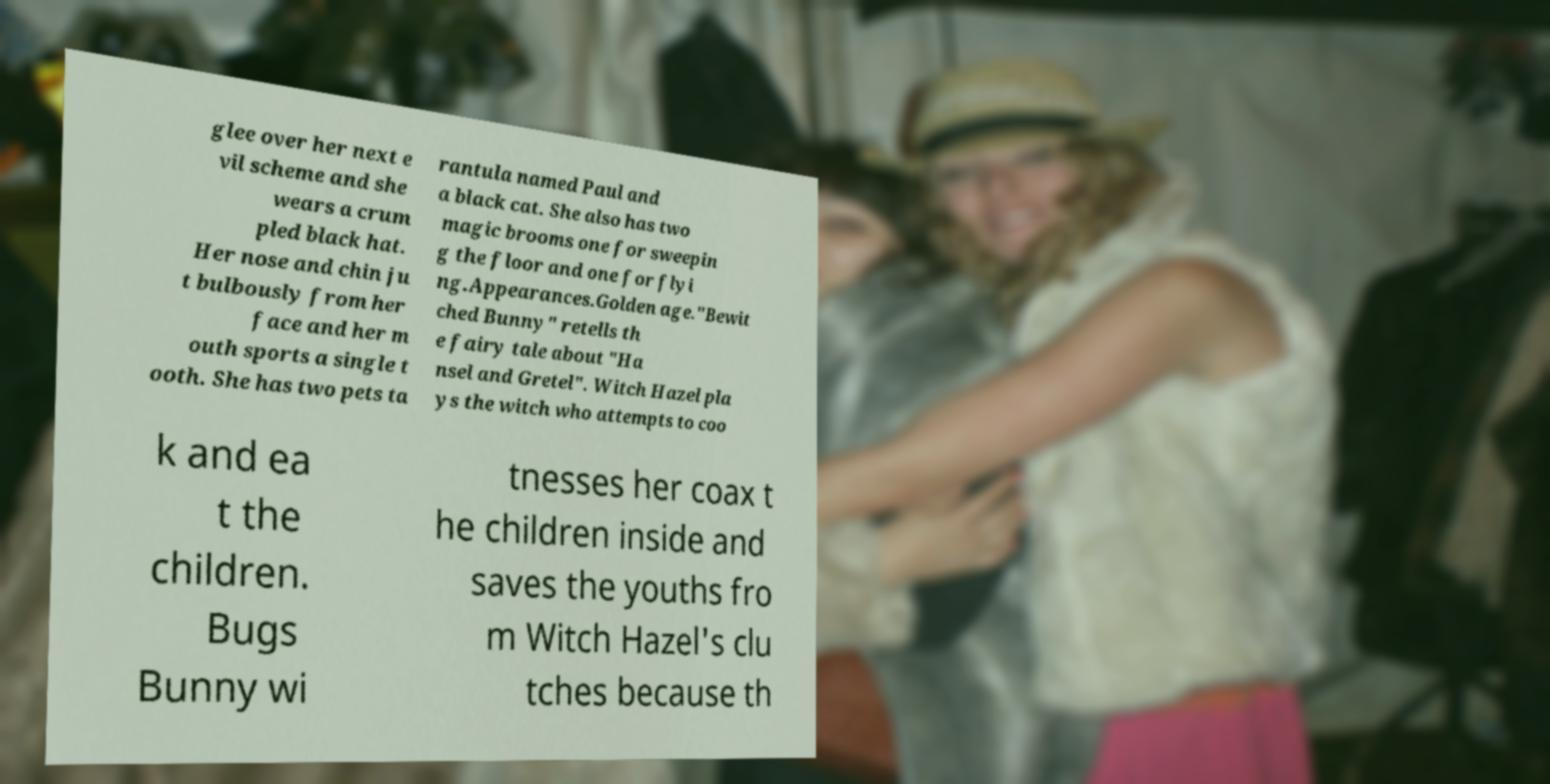Can you accurately transcribe the text from the provided image for me? glee over her next e vil scheme and she wears a crum pled black hat. Her nose and chin ju t bulbously from her face and her m outh sports a single t ooth. She has two pets ta rantula named Paul and a black cat. She also has two magic brooms one for sweepin g the floor and one for flyi ng.Appearances.Golden age."Bewit ched Bunny" retells th e fairy tale about "Ha nsel and Gretel". Witch Hazel pla ys the witch who attempts to coo k and ea t the children. Bugs Bunny wi tnesses her coax t he children inside and saves the youths fro m Witch Hazel's clu tches because th 